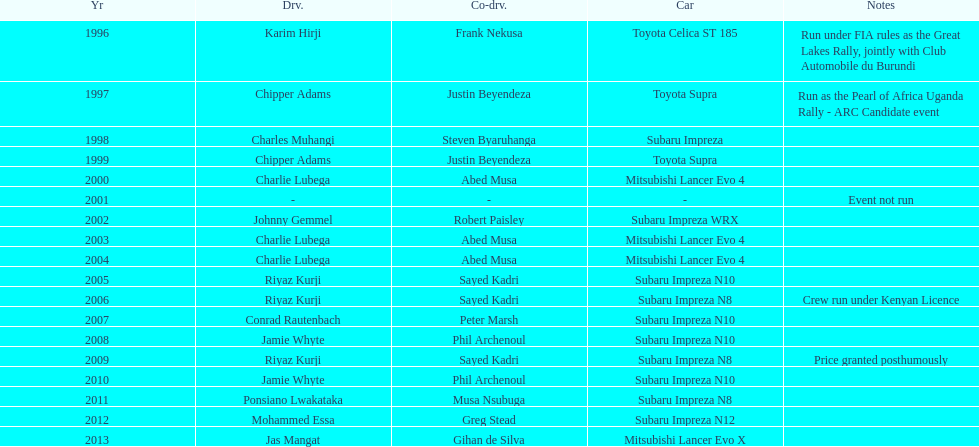How many drivers won at least twice? 4. Give me the full table as a dictionary. {'header': ['Yr', 'Drv.', 'Co-drv.', 'Car', 'Notes'], 'rows': [['1996', 'Karim Hirji', 'Frank Nekusa', 'Toyota Celica ST 185', 'Run under FIA rules as the Great Lakes Rally, jointly with Club Automobile du Burundi'], ['1997', 'Chipper Adams', 'Justin Beyendeza', 'Toyota Supra', 'Run as the Pearl of Africa Uganda Rally - ARC Candidate event'], ['1998', 'Charles Muhangi', 'Steven Byaruhanga', 'Subaru Impreza', ''], ['1999', 'Chipper Adams', 'Justin Beyendeza', 'Toyota Supra', ''], ['2000', 'Charlie Lubega', 'Abed Musa', 'Mitsubishi Lancer Evo 4', ''], ['2001', '-', '-', '-', 'Event not run'], ['2002', 'Johnny Gemmel', 'Robert Paisley', 'Subaru Impreza WRX', ''], ['2003', 'Charlie Lubega', 'Abed Musa', 'Mitsubishi Lancer Evo 4', ''], ['2004', 'Charlie Lubega', 'Abed Musa', 'Mitsubishi Lancer Evo 4', ''], ['2005', 'Riyaz Kurji', 'Sayed Kadri', 'Subaru Impreza N10', ''], ['2006', 'Riyaz Kurji', 'Sayed Kadri', 'Subaru Impreza N8', 'Crew run under Kenyan Licence'], ['2007', 'Conrad Rautenbach', 'Peter Marsh', 'Subaru Impreza N10', ''], ['2008', 'Jamie Whyte', 'Phil Archenoul', 'Subaru Impreza N10', ''], ['2009', 'Riyaz Kurji', 'Sayed Kadri', 'Subaru Impreza N8', 'Price granted posthumously'], ['2010', 'Jamie Whyte', 'Phil Archenoul', 'Subaru Impreza N10', ''], ['2011', 'Ponsiano Lwakataka', 'Musa Nsubuga', 'Subaru Impreza N8', ''], ['2012', 'Mohammed Essa', 'Greg Stead', 'Subaru Impreza N12', ''], ['2013', 'Jas Mangat', 'Gihan de Silva', 'Mitsubishi Lancer Evo X', '']]} 